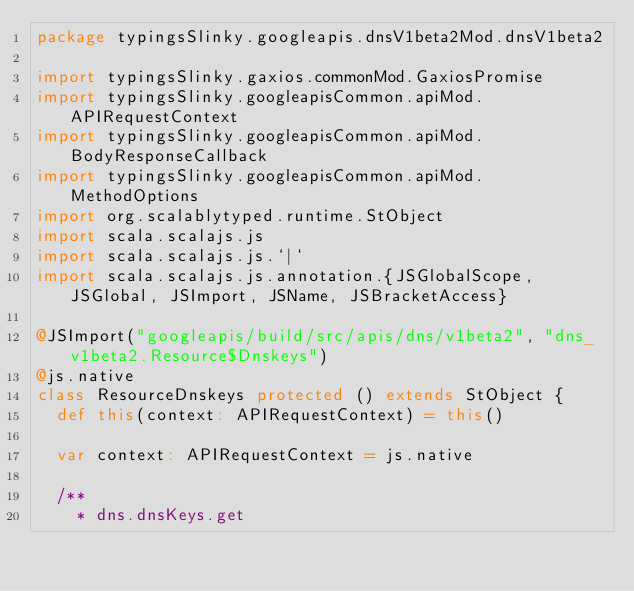Convert code to text. <code><loc_0><loc_0><loc_500><loc_500><_Scala_>package typingsSlinky.googleapis.dnsV1beta2Mod.dnsV1beta2

import typingsSlinky.gaxios.commonMod.GaxiosPromise
import typingsSlinky.googleapisCommon.apiMod.APIRequestContext
import typingsSlinky.googleapisCommon.apiMod.BodyResponseCallback
import typingsSlinky.googleapisCommon.apiMod.MethodOptions
import org.scalablytyped.runtime.StObject
import scala.scalajs.js
import scala.scalajs.js.`|`
import scala.scalajs.js.annotation.{JSGlobalScope, JSGlobal, JSImport, JSName, JSBracketAccess}

@JSImport("googleapis/build/src/apis/dns/v1beta2", "dns_v1beta2.Resource$Dnskeys")
@js.native
class ResourceDnskeys protected () extends StObject {
  def this(context: APIRequestContext) = this()
  
  var context: APIRequestContext = js.native
  
  /**
    * dns.dnsKeys.get</code> 